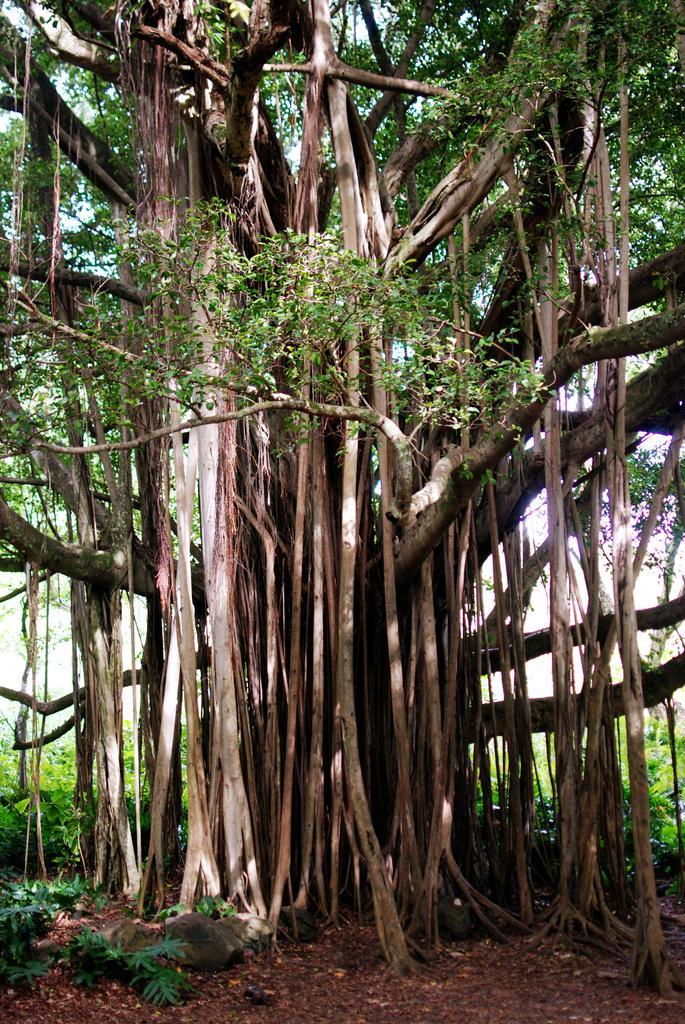What type of tree is in the image? There is a banyan tree in the image. What other types of vegetation can be seen in the image? There are plants in the image. What inorganic objects are present in the image? There are stones in the image. What is located at the bottom of the image? Dried leaves are present at the bottom of the image. What type of memory does the woman have in the image? There is no woman present in the image, so it is not possible to determine what type of memory she might have. 